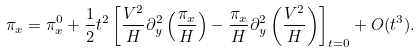Convert formula to latex. <formula><loc_0><loc_0><loc_500><loc_500>\pi _ { x } = \pi _ { x } ^ { 0 } + \frac { 1 } { 2 } t ^ { 2 } \left [ \frac { V ^ { 2 } } { H } \partial _ { y } ^ { 2 } \left ( \frac { \pi _ { x } } { H } \right ) - \frac { \pi _ { x } } { H } \partial _ { y } ^ { 2 } \left ( \frac { V ^ { 2 } } { H } \right ) \right ] _ { t = 0 } + O ( t ^ { 3 } ) .</formula> 